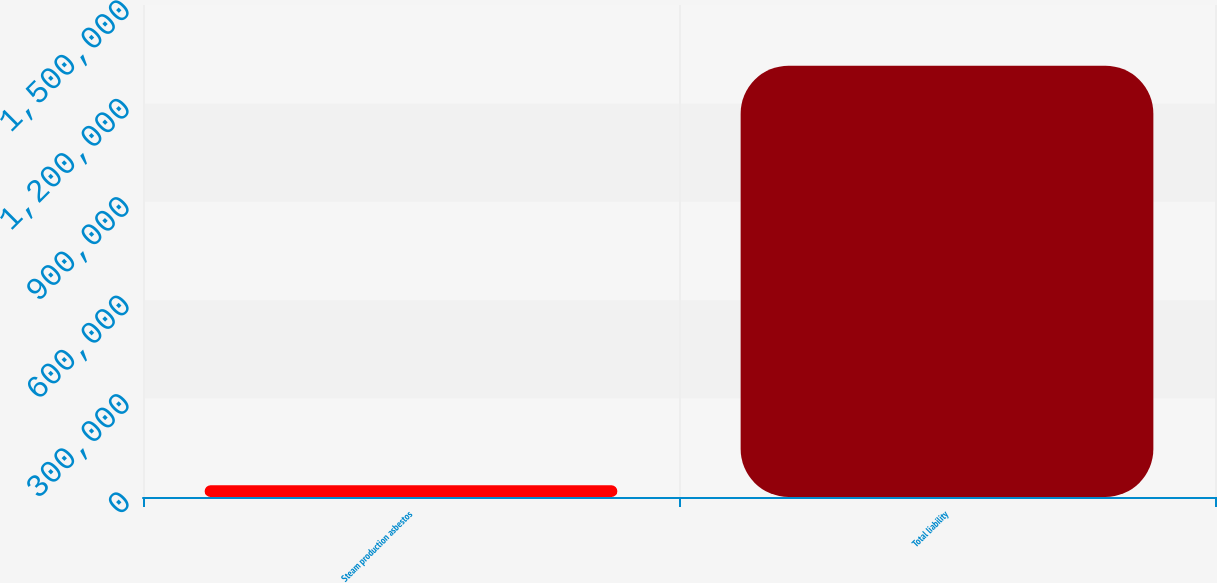<chart> <loc_0><loc_0><loc_500><loc_500><bar_chart><fcel>Steam production asbestos<fcel>Total liability<nl><fcel>35807<fcel>1.31514e+06<nl></chart> 